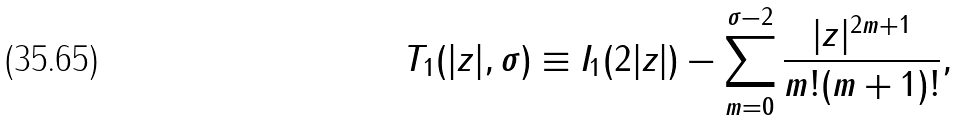<formula> <loc_0><loc_0><loc_500><loc_500>T _ { 1 } ( | z | , \sigma ) \equiv I _ { 1 } ( 2 | z | ) - \sum _ { m = 0 } ^ { \sigma - 2 } \frac { | z | ^ { 2 m + 1 } } { m ! ( m + 1 ) ! } ,</formula> 